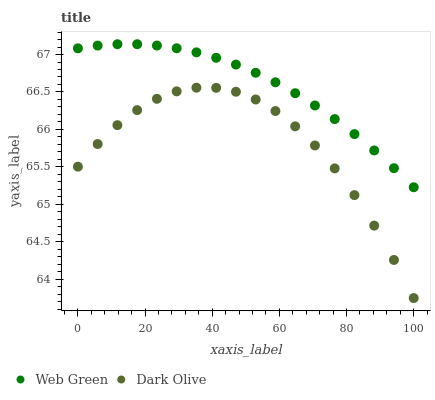Does Dark Olive have the minimum area under the curve?
Answer yes or no. Yes. Does Web Green have the maximum area under the curve?
Answer yes or no. Yes. Does Web Green have the minimum area under the curve?
Answer yes or no. No. Is Web Green the smoothest?
Answer yes or no. Yes. Is Dark Olive the roughest?
Answer yes or no. Yes. Is Web Green the roughest?
Answer yes or no. No. Does Dark Olive have the lowest value?
Answer yes or no. Yes. Does Web Green have the lowest value?
Answer yes or no. No. Does Web Green have the highest value?
Answer yes or no. Yes. Is Dark Olive less than Web Green?
Answer yes or no. Yes. Is Web Green greater than Dark Olive?
Answer yes or no. Yes. Does Dark Olive intersect Web Green?
Answer yes or no. No. 